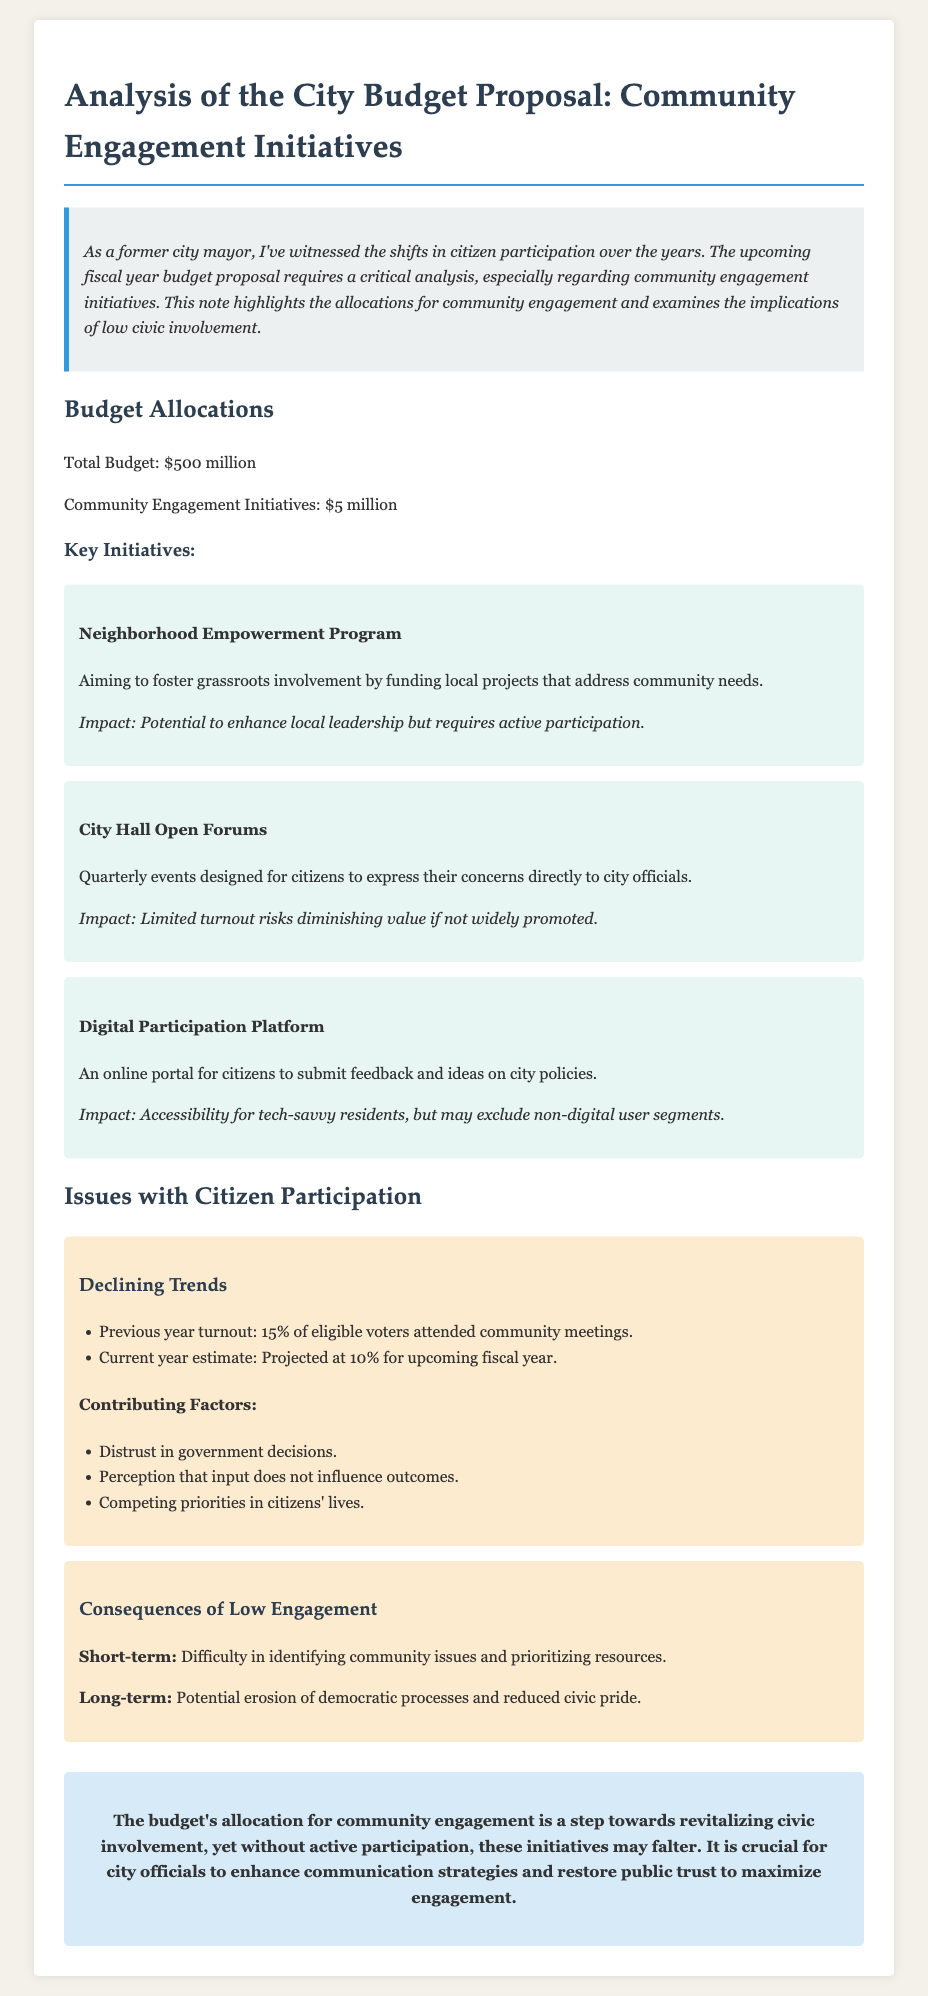What is the total budget for the upcoming fiscal year? The total budget is explicitly stated in the document.
Answer: $500 million How much is allocated for community engagement initiatives? The allocation for community engagement initiatives is mentioned as a specific amount in the document.
Answer: $5 million What is one of the key initiatives for community engagement? The document lists specific programs under key initiatives for community engagement.
Answer: Neighborhood Empowerment Program What is the projected turnout for the current year? The document provides a projection for the upcoming fiscal year based on previous trends.
Answer: 10% What are one of the contributing factors to declining citizen participation? The document lists multiple factors affecting citizen participation, and this is one of them.
Answer: Distrust in government decisions What is a short-term consequence of low engagement mentioned in the document? The document describes various short-term and long-term consequences of low engagement.
Answer: Difficulty in identifying community issues What do the City Hall Open Forums aim to achieve? The purpose of the forum is detailed in the description of the initiative in the document.
Answer: Allow citizens to express concerns What does the digital participation platform provide? The document indicates the main function of the digital participation platform for citizens.
Answer: Online portal for feedback and ideas What is emphasized as crucial for maximizing engagement? The conclusion suggests necessary steps for improving civic participation based on the analysis.
Answer: Enhance communication strategies 